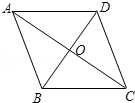What geometric principles can be observed in the structural design seen in the image? The image illustrates a diamond or rhombus shape, embodying geometric principles such as symmetry, the 90-degree angles between the diagonals, and bisected lines. This structure also exemplifies how shapes manage space and stability within a design, a principle quite pivotal in architectural geometries and designs. 